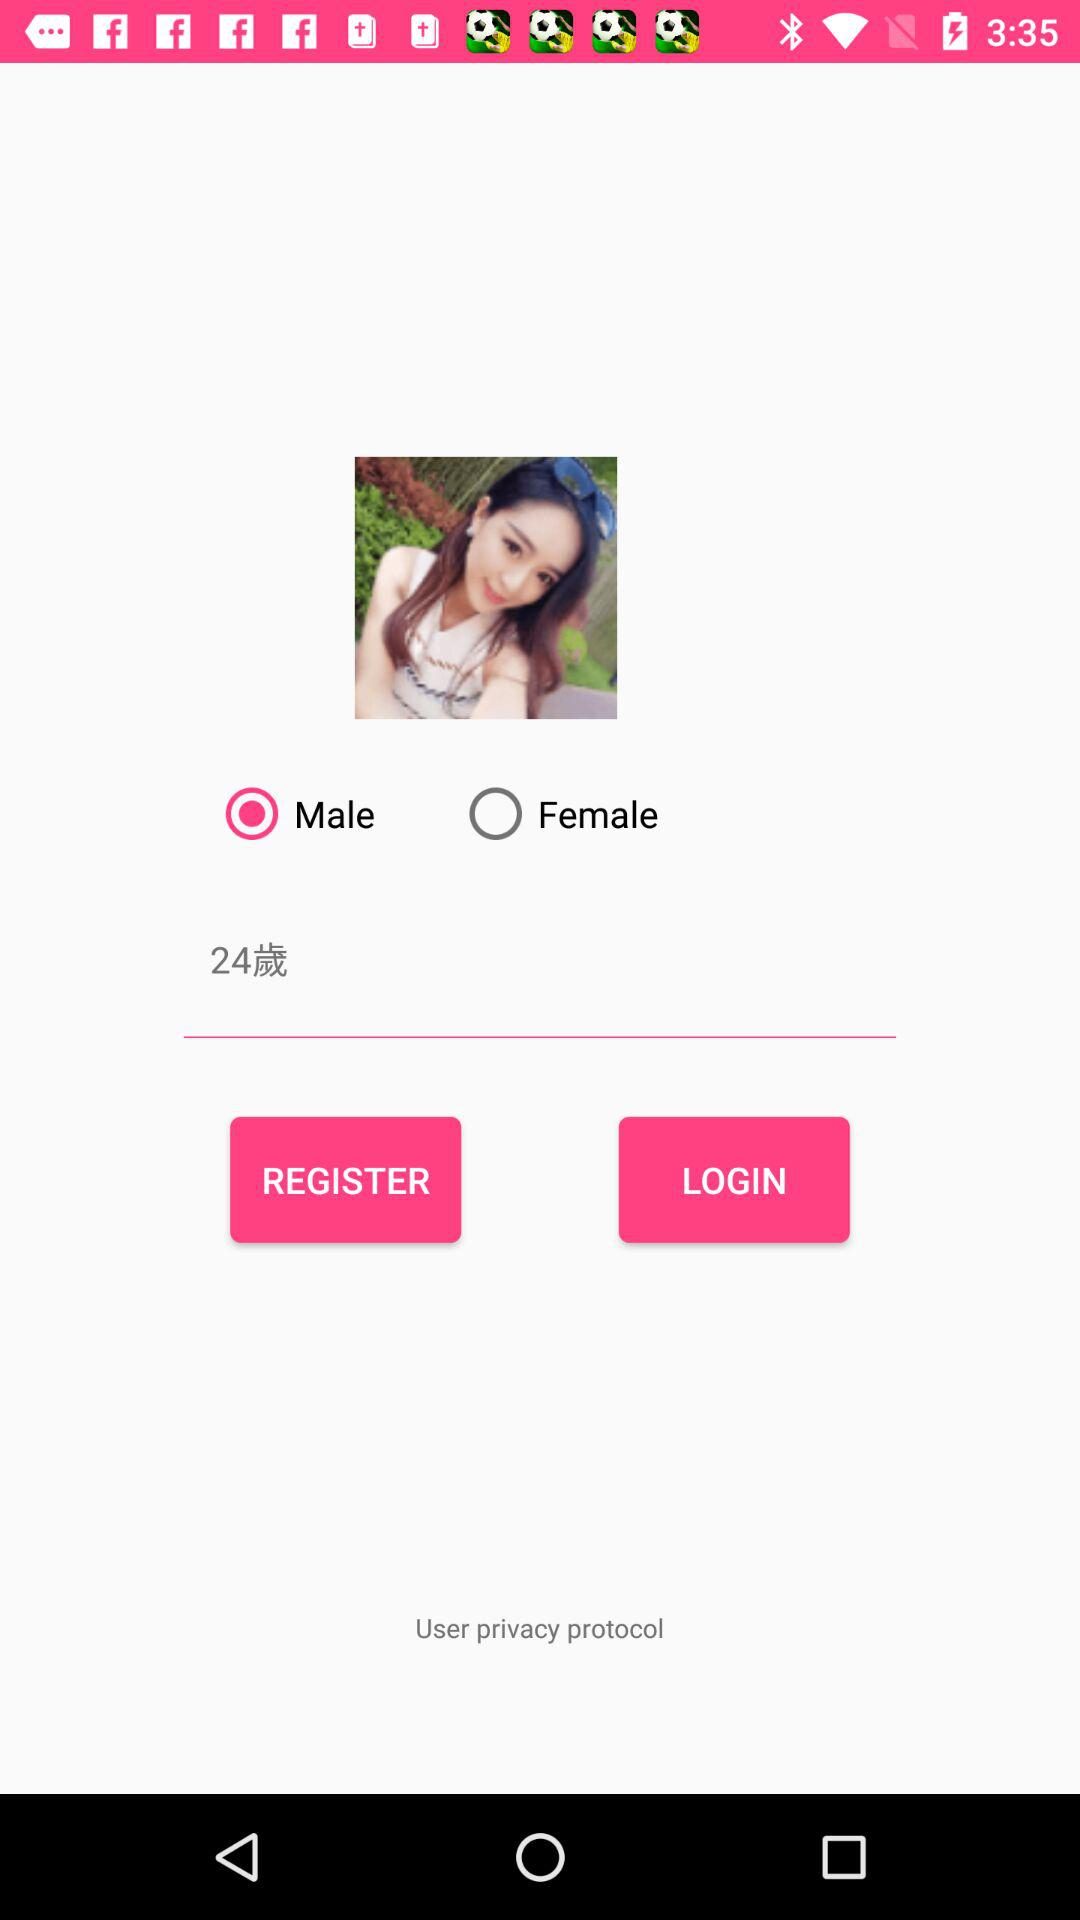What is the selected gender? The selected gender is male. 